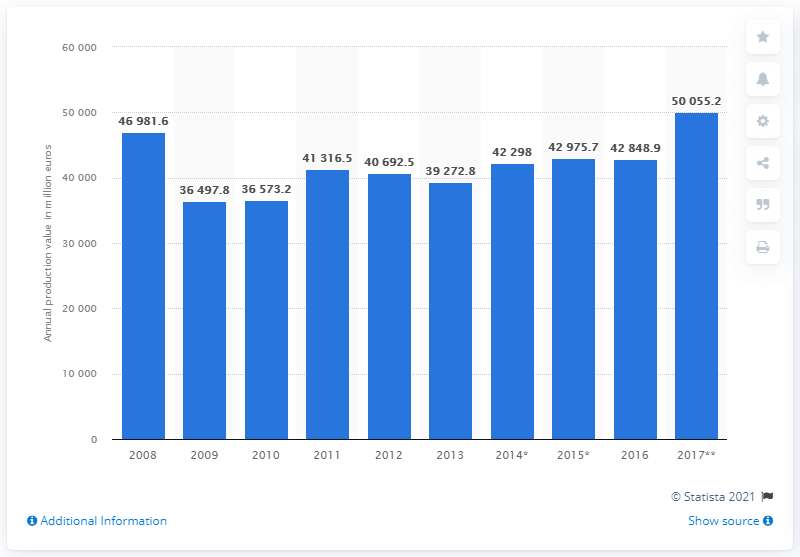Mention a couple of crucial points in this snapshot. According to data from 2016, the production value of the manufacture of machinery and equipment industry in France was 42,848.9 million euros. 